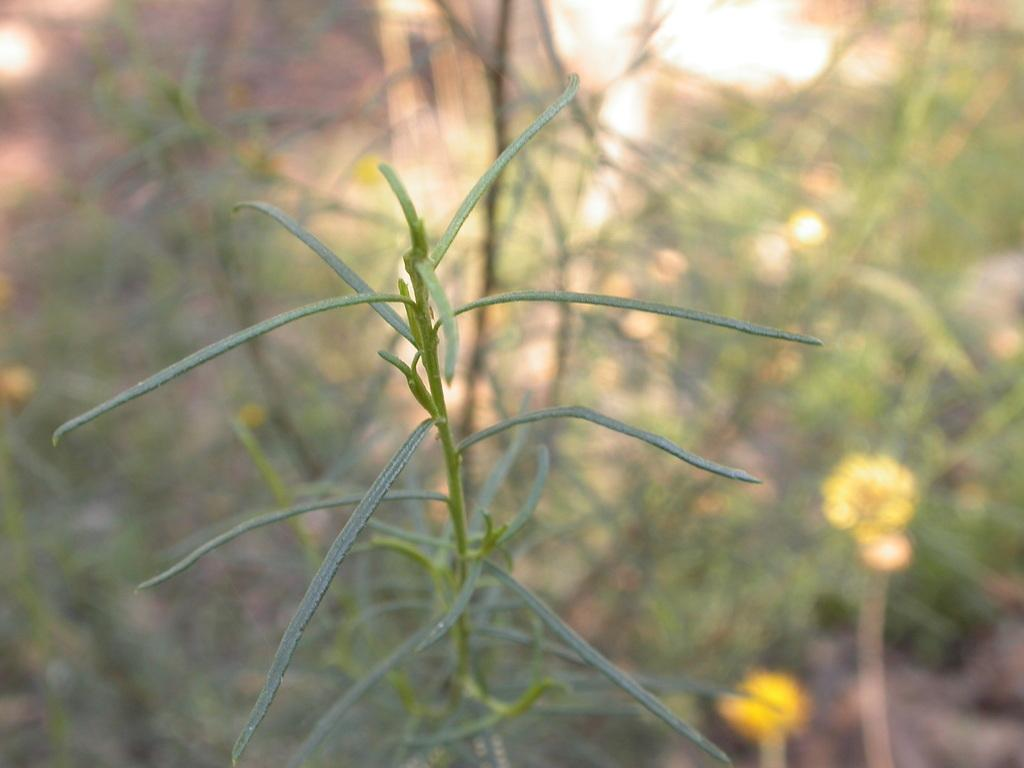What is the main subject of the image? There is a plant in the image. Can you describe the background of the image? The background of the image is blurred and green in color. Where is the toothbrush located in the image? There is no toothbrush present in the image. What is the level of noise in the image? The image does not convey any information about the level of noise, as it only features a plant and a blurred green background. 